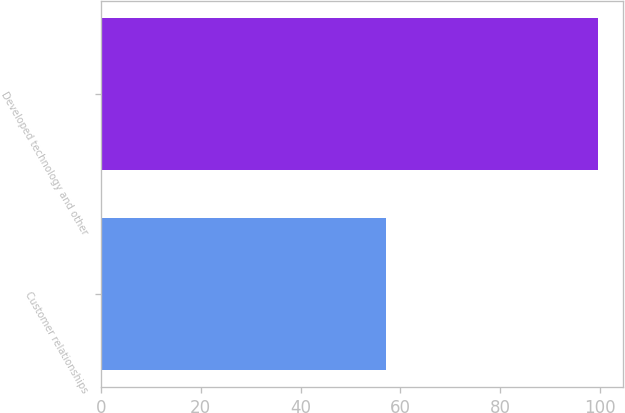Convert chart to OTSL. <chart><loc_0><loc_0><loc_500><loc_500><bar_chart><fcel>Customer relationships<fcel>Developed technology and other<nl><fcel>57.2<fcel>99.7<nl></chart> 